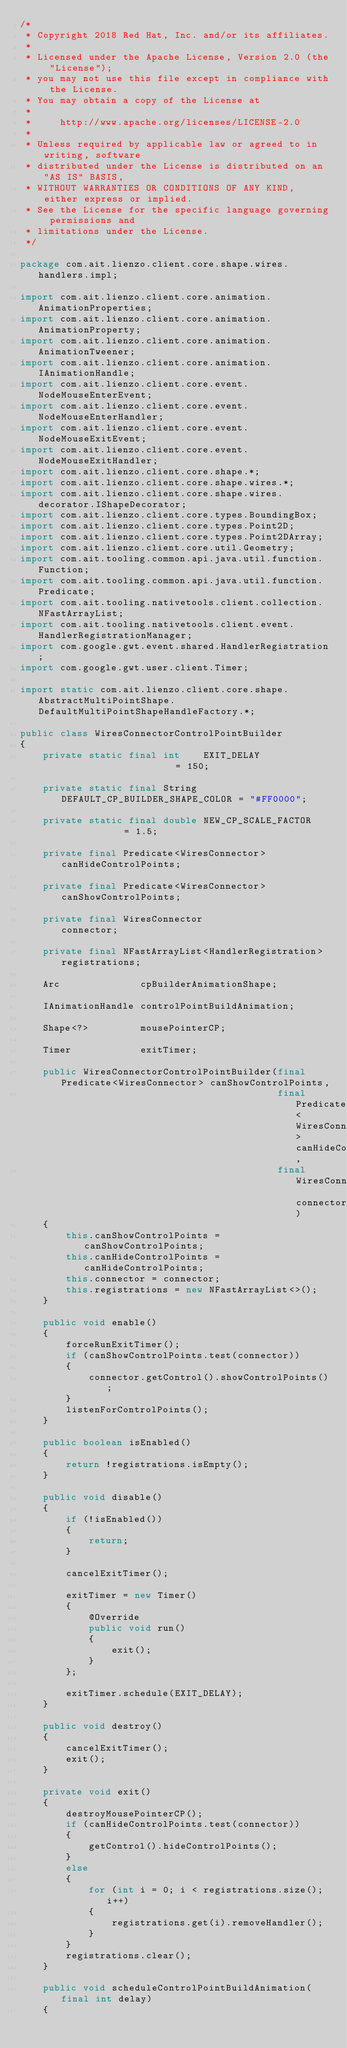Convert code to text. <code><loc_0><loc_0><loc_500><loc_500><_Java_>/*
 * Copyright 2018 Red Hat, Inc. and/or its affiliates.
 *
 * Licensed under the Apache License, Version 2.0 (the "License");
 * you may not use this file except in compliance with the License.
 * You may obtain a copy of the License at
 *
 *     http://www.apache.org/licenses/LICENSE-2.0
 *
 * Unless required by applicable law or agreed to in writing, software
 * distributed under the License is distributed on an "AS IS" BASIS,
 * WITHOUT WARRANTIES OR CONDITIONS OF ANY KIND, either express or implied.
 * See the License for the specific language governing permissions and
 * limitations under the License.
 */

package com.ait.lienzo.client.core.shape.wires.handlers.impl;

import com.ait.lienzo.client.core.animation.AnimationProperties;
import com.ait.lienzo.client.core.animation.AnimationProperty;
import com.ait.lienzo.client.core.animation.AnimationTweener;
import com.ait.lienzo.client.core.animation.IAnimationHandle;
import com.ait.lienzo.client.core.event.NodeMouseEnterEvent;
import com.ait.lienzo.client.core.event.NodeMouseEnterHandler;
import com.ait.lienzo.client.core.event.NodeMouseExitEvent;
import com.ait.lienzo.client.core.event.NodeMouseExitHandler;
import com.ait.lienzo.client.core.shape.*;
import com.ait.lienzo.client.core.shape.wires.*;
import com.ait.lienzo.client.core.shape.wires.decorator.IShapeDecorator;
import com.ait.lienzo.client.core.types.BoundingBox;
import com.ait.lienzo.client.core.types.Point2D;
import com.ait.lienzo.client.core.types.Point2DArray;
import com.ait.lienzo.client.core.util.Geometry;
import com.ait.tooling.common.api.java.util.function.Function;
import com.ait.tooling.common.api.java.util.function.Predicate;
import com.ait.tooling.nativetools.client.collection.NFastArrayList;
import com.ait.tooling.nativetools.client.event.HandlerRegistrationManager;
import com.google.gwt.event.shared.HandlerRegistration;
import com.google.gwt.user.client.Timer;

import static com.ait.lienzo.client.core.shape.AbstractMultiPointShape.DefaultMultiPointShapeHandleFactory.*;

public class WiresConnectorControlPointBuilder
{
    private static final int    EXIT_DELAY                     = 150;

    private static final String DEFAULT_CP_BUILDER_SHAPE_COLOR = "#FF0000";

    private static final double NEW_CP_SCALE_FACTOR            = 1.5;

    private final Predicate<WiresConnector>           canHideControlPoints;

    private final Predicate<WiresConnector>           canShowControlPoints;

    private final WiresConnector                      connector;

    private final NFastArrayList<HandlerRegistration> registrations;

    Arc              cpBuilderAnimationShape;

    IAnimationHandle controlPointBuildAnimation;

    Shape<?>         mousePointerCP;

    Timer            exitTimer;

    public WiresConnectorControlPointBuilder(final Predicate<WiresConnector> canShowControlPoints,
                                             final Predicate<WiresConnector> canHideControlPoints,
                                             final WiresConnector connector)
    {
        this.canShowControlPoints = canShowControlPoints;
        this.canHideControlPoints = canHideControlPoints;
        this.connector = connector;
        this.registrations = new NFastArrayList<>();
    }

    public void enable()
    {
        forceRunExitTimer();
        if (canShowControlPoints.test(connector))
        {
            connector.getControl().showControlPoints();
        }
        listenForControlPoints();
    }

    public boolean isEnabled()
    {
        return !registrations.isEmpty();
    }

    public void disable()
    {
        if (!isEnabled())
        {
            return;
        }

        cancelExitTimer();

        exitTimer = new Timer()
        {
            @Override
            public void run()
            {
                exit();
            }
        };

        exitTimer.schedule(EXIT_DELAY);
    }

    public void destroy()
    {
        cancelExitTimer();
        exit();
    }

    private void exit()
    {
        destroyMousePointerCP();
        if (canHideControlPoints.test(connector))
        {
            getControl().hideControlPoints();
        }
        else
        {
            for (int i = 0; i < registrations.size(); i++)
            {
                registrations.get(i).removeHandler();
            }
        }
        registrations.clear();
    }

    public void scheduleControlPointBuildAnimation(final int delay)
    {</code> 